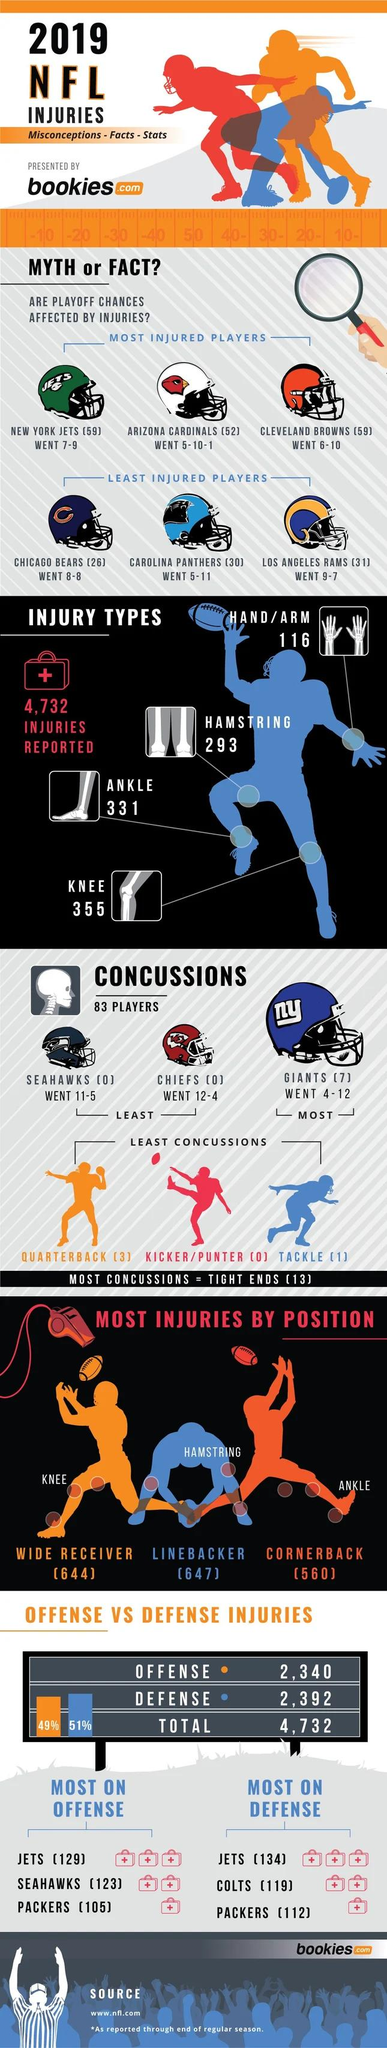Highlight a few significant elements in this photo. The most commonly reported injury type among players during the 2019 NFL games was knee injuries. In 2019, there were a total of 4,732 reported injuries in National Football League games. The NFL team with the highest number of reported concussions in 2019 games is the New England Patriots. During the 2019 NFL season, a total of 3 ankle injuries were reported. What is written on the Giant's helmet? Nothing. 